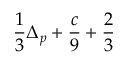<formula> <loc_0><loc_0><loc_500><loc_500>\frac { 1 } { 3 } \Delta _ { p } + \frac { c } { 9 } + \frac { 2 } { 3 }</formula> 